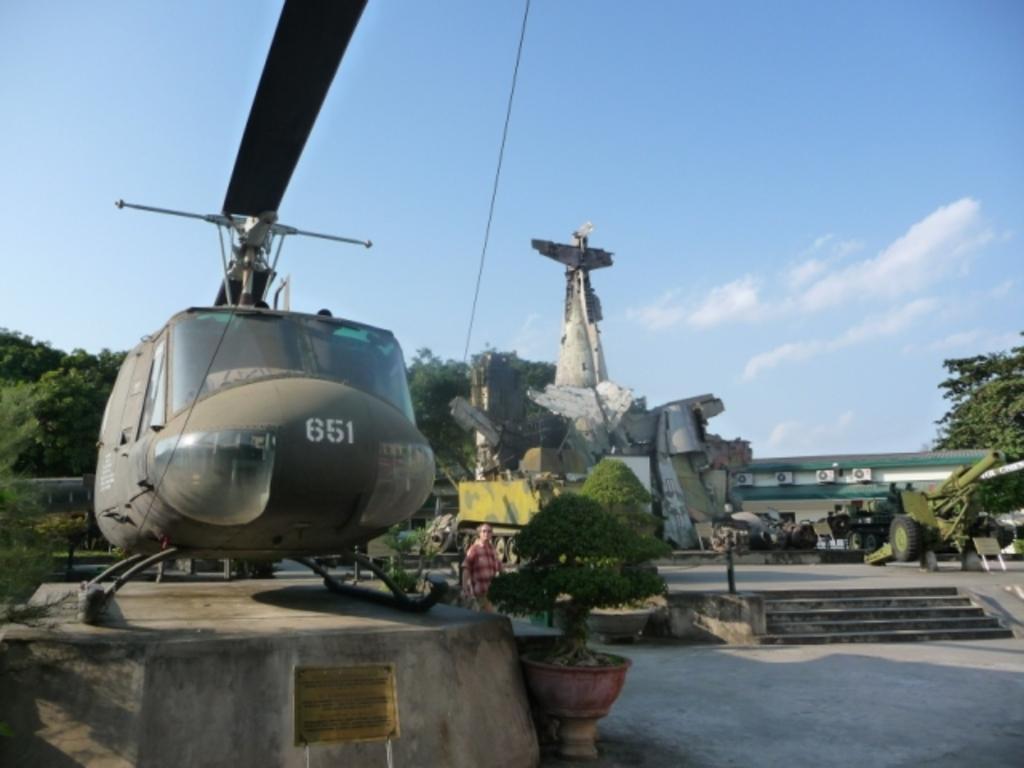Describe this image in one or two sentences. In the foreground I can see an aircraft, houseplants and a person on the road. In the background I can see vehicles, statue, trees, building and the sky. This image is taken during a sunny day. 